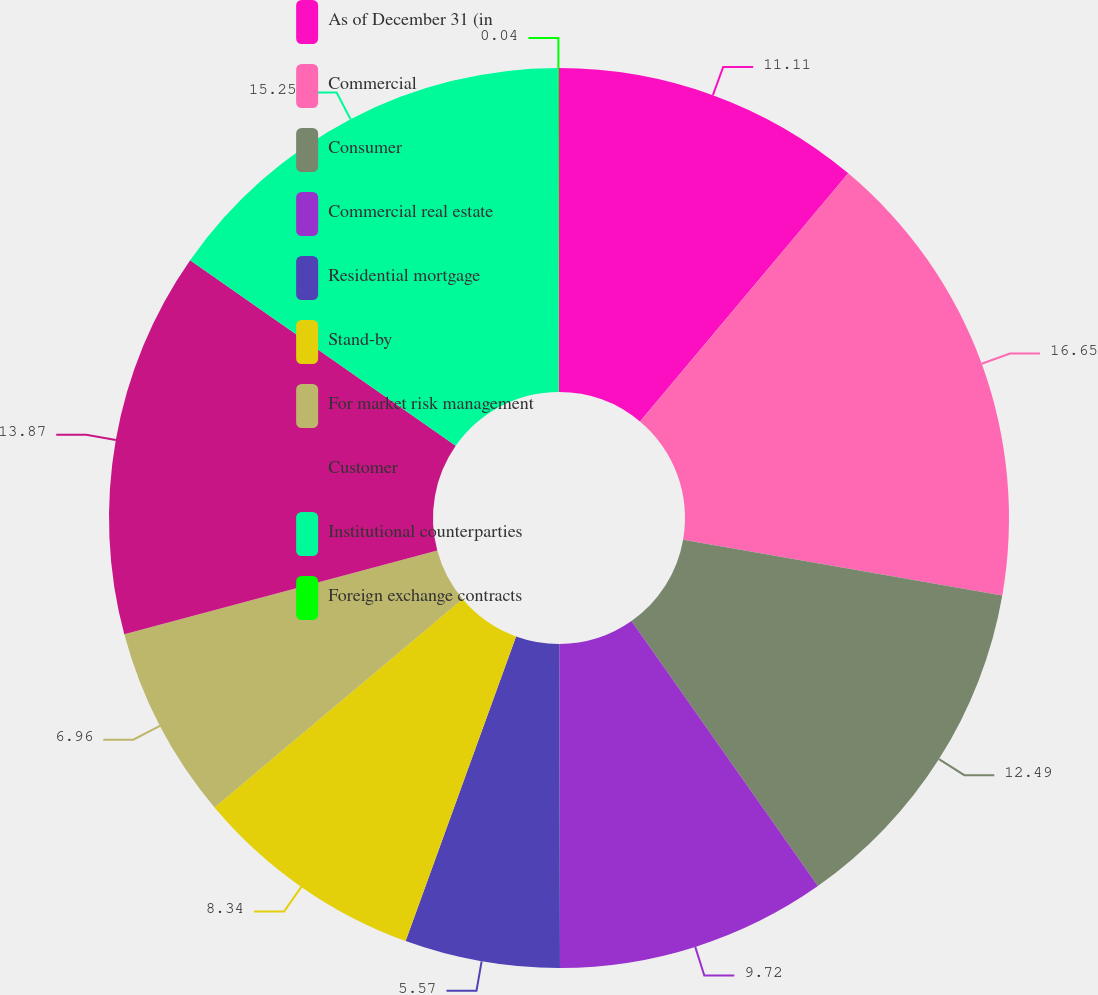<chart> <loc_0><loc_0><loc_500><loc_500><pie_chart><fcel>As of December 31 (in<fcel>Commercial<fcel>Consumer<fcel>Commercial real estate<fcel>Residential mortgage<fcel>Stand-by<fcel>For market risk management<fcel>Customer<fcel>Institutional counterparties<fcel>Foreign exchange contracts<nl><fcel>11.11%<fcel>16.64%<fcel>12.49%<fcel>9.72%<fcel>5.57%<fcel>8.34%<fcel>6.96%<fcel>13.87%<fcel>15.25%<fcel>0.04%<nl></chart> 